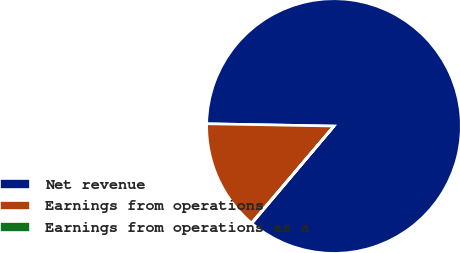Convert chart to OTSL. <chart><loc_0><loc_0><loc_500><loc_500><pie_chart><fcel>Net revenue<fcel>Earnings from operations<fcel>Earnings from operations as a<nl><fcel>85.87%<fcel>14.07%<fcel>0.06%<nl></chart> 